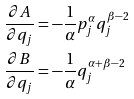Convert formula to latex. <formula><loc_0><loc_0><loc_500><loc_500>& \frac { \partial A } { \partial q _ { j } } = - \frac { 1 } { \alpha } p ^ { \alpha } _ { j } q ^ { \beta - 2 } _ { j } \\ & \frac { \partial B } { \partial q _ { j } } = - \frac { 1 } { \alpha } q ^ { \alpha + \beta - 2 } _ { j }</formula> 